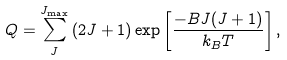<formula> <loc_0><loc_0><loc_500><loc_500>Q = \sum _ { J } ^ { J _ { \max } } \left ( 2 J + 1 \right ) \exp \left [ \frac { - B J ( J + 1 ) } { k _ { B } T } \right ] ,</formula> 